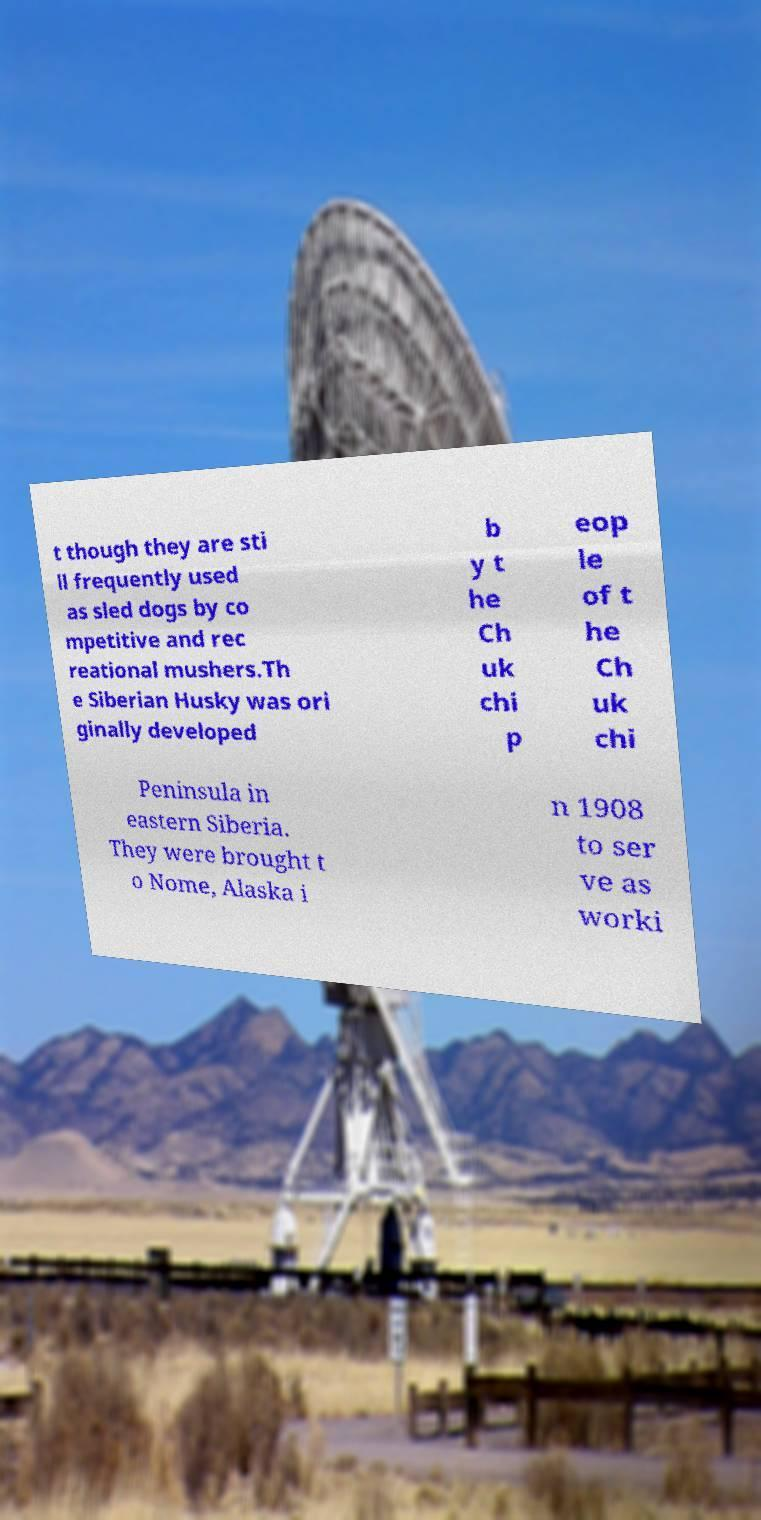Can you accurately transcribe the text from the provided image for me? t though they are sti ll frequently used as sled dogs by co mpetitive and rec reational mushers.Th e Siberian Husky was ori ginally developed b y t he Ch uk chi p eop le of t he Ch uk chi Peninsula in eastern Siberia. They were brought t o Nome, Alaska i n 1908 to ser ve as worki 